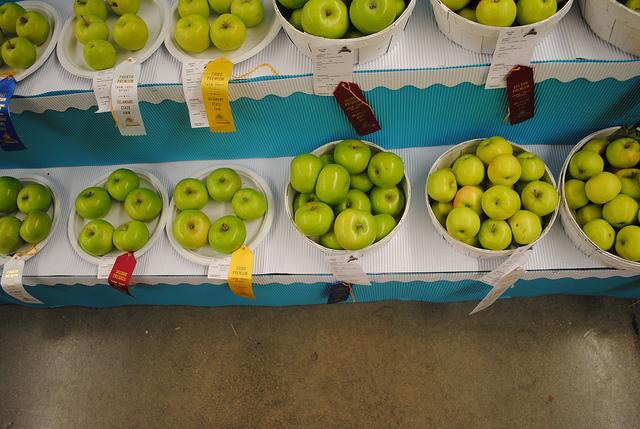How many apples are in the plate with the yellow ribbon?
Answer briefly. 5. How many ribbons are on display?
Concise answer only. 10. What do the ribbons mean?
Quick response, please. Awards won. 